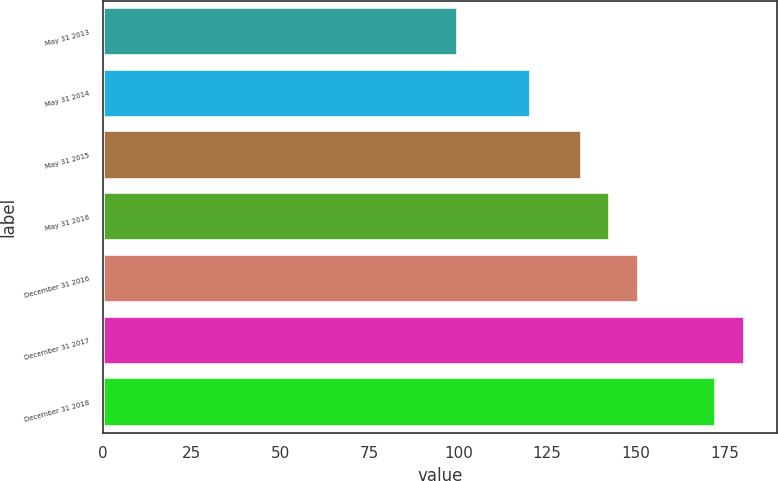Convert chart to OTSL. <chart><loc_0><loc_0><loc_500><loc_500><bar_chart><fcel>May 31 2013<fcel>May 31 2014<fcel>May 31 2015<fcel>May 31 2016<fcel>December 31 2016<fcel>December 31 2017<fcel>December 31 2018<nl><fcel>100<fcel>120.45<fcel>134.67<fcel>142.71<fcel>150.75<fcel>180.54<fcel>172.5<nl></chart> 